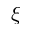Convert formula to latex. <formula><loc_0><loc_0><loc_500><loc_500>\xi</formula> 